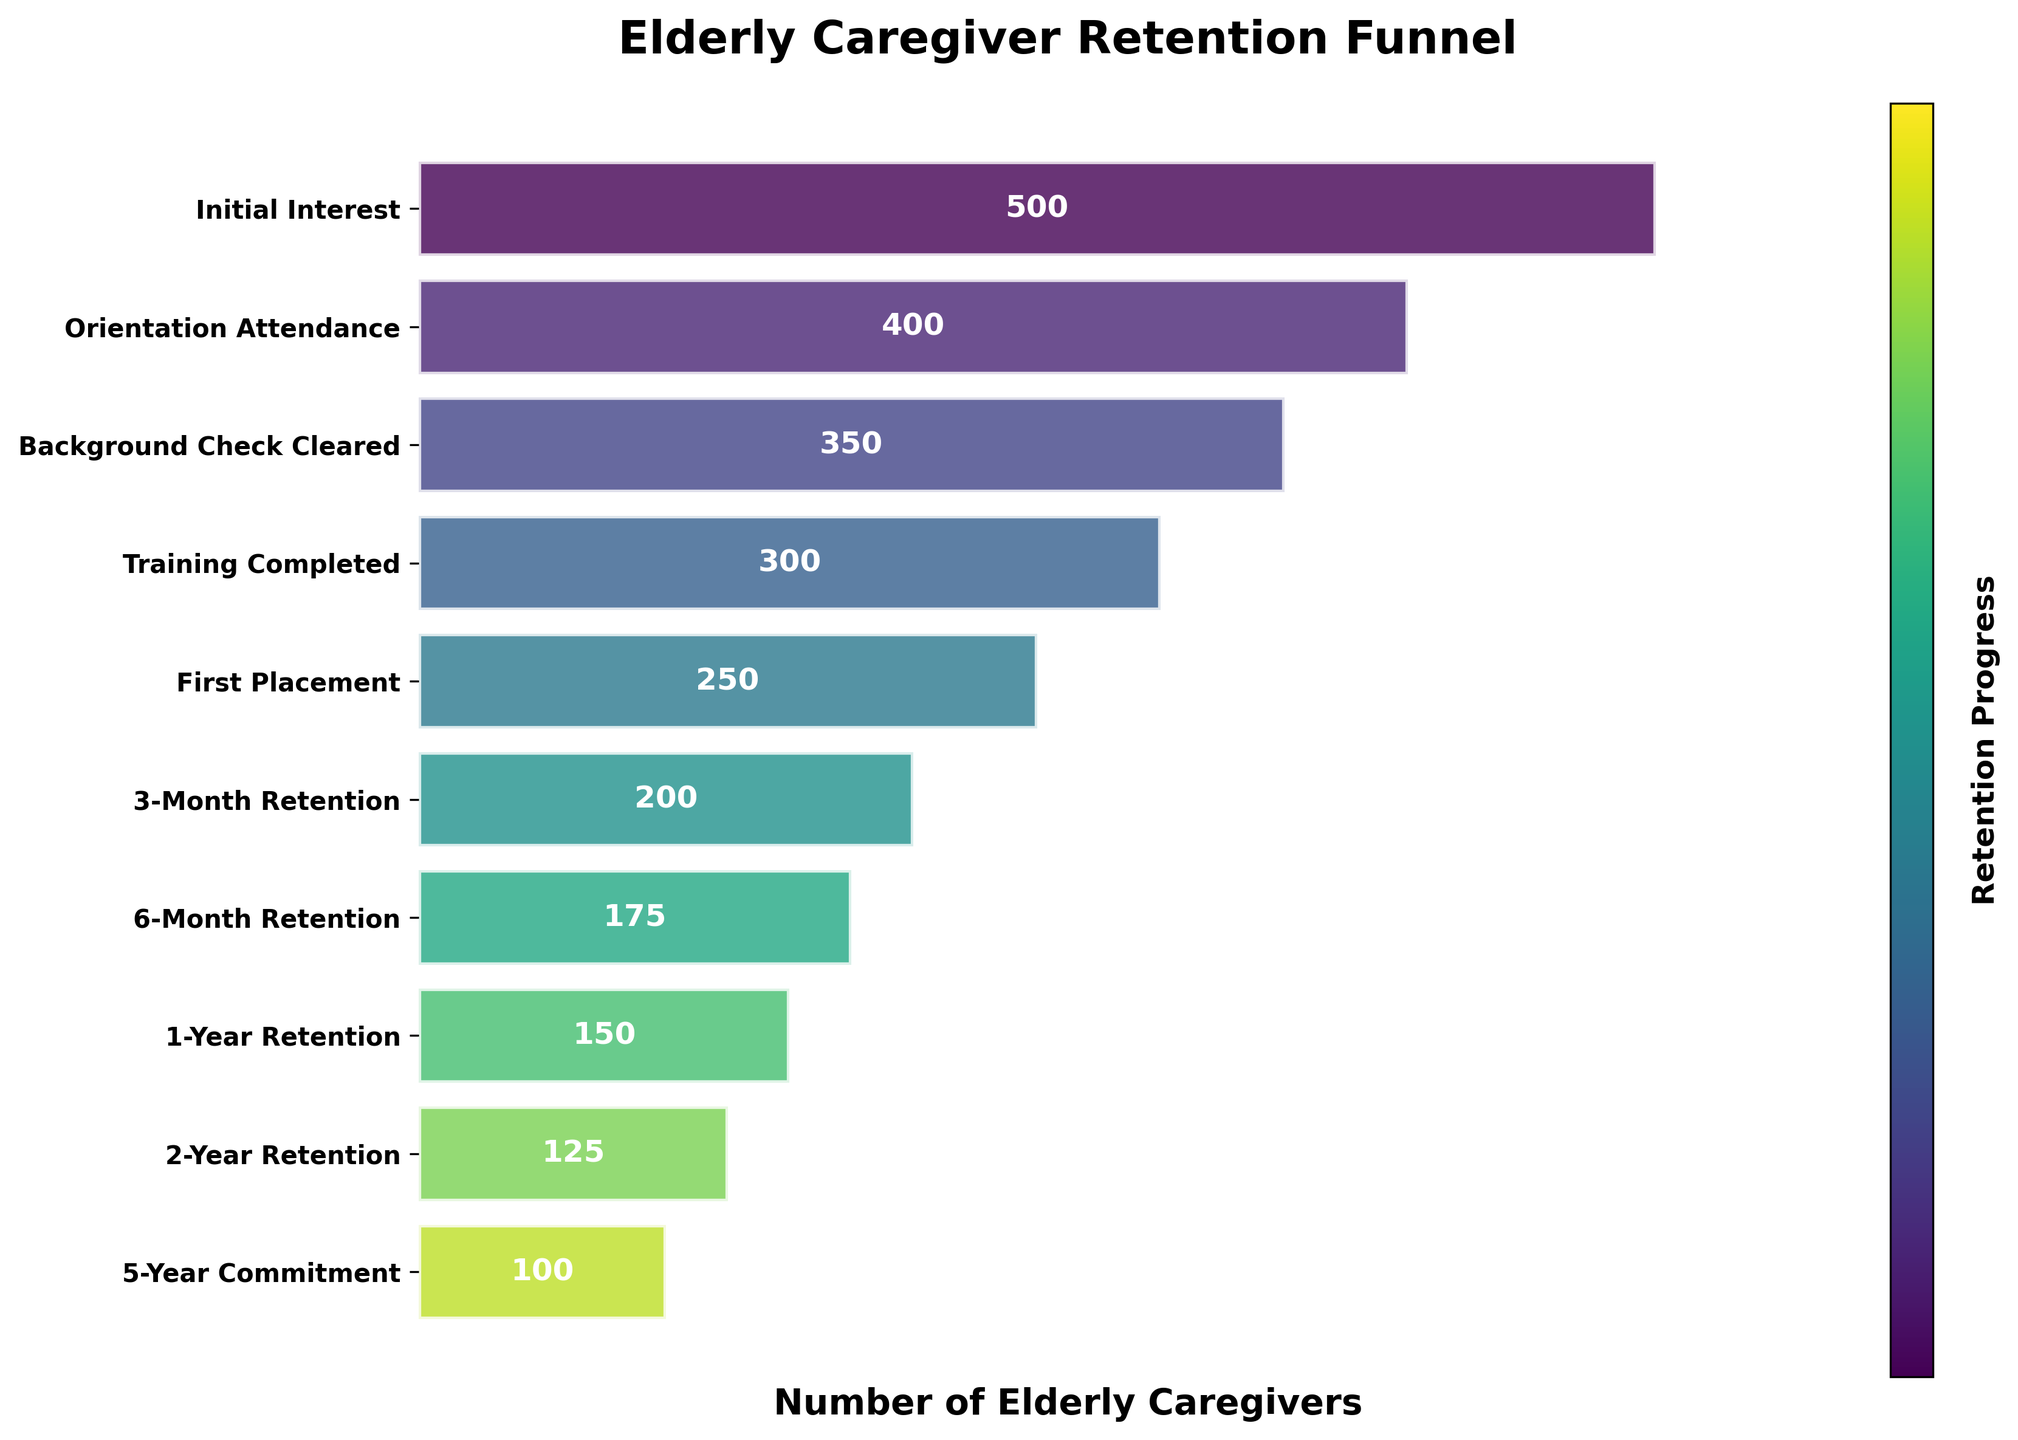What's the title of the figure? The title is usually displayed prominently at the top of a figure. In this case, it is mentioned in the code.
Answer: Elderly Caregiver Retention Funnel How many stages are shown in the funnel chart? Counting the number of stages listed on the y-axis in the figure, we see there are ten stages.
Answer: 10 What is the number of elderly caregivers at the 'Orientation Attendance' stage? From the figure, identify the bar corresponding to the 'Orientation Attendance' stage and read the label inside or on top of the bar.
Answer: 400 How many elderly caregivers completed the 'Training' stage? Locate the 'Training Completed' stage on the y-axis and read the value from the figure.
Answer: 300 Which stage has the largest drop in the number of elderly caregivers compared to the previous stage? Compare the difference in numbers between each consecutive stage by subtracting the values. The largest drop happens between 'Initial Interest' (500) and 'Orientation Attendance' (400).
Answer: Orientation Attendance What is the difference in the number of elderly caregivers between the '3-Month Retention' and '6-Month Retention' stages? Subtract the number at '6-Month Retention' (175) from that at '3-Month Retention' (200): 200 - 175 = 25.
Answer: 25 Which stage marks the halfway point in the number of elderly caregivers from 'Initial Interest' to '5-Year Commitment'? Calculate the halfway number, which is (500 + 100) / 2 = 300, then find the stage closest to this number in the figure. 'Training Completed' is 300.
Answer: Training Completed What is the total number of elderly caregivers retained after the '1-Year Retention' stage? Sum the values from '1-Year Retention' (150) to '5-Year Commitment' (100): 150 + 125 + 100 = 375.
Answer: 375 How does the color scheme progress through the stages? Observe the changes in the colors of the bars from top to bottom. The plot uses a viridis color map which gradually transitions from one color to another as you move down the stages.
Answer: Gradual transition What percentage of elderly caregivers retained after the '6-Month Retention' stage? Divide the '6-Month Retention' number (175) by the 'Initial Interest' number (500) and multiply by 100 to get the percentage: (175 / 500) * 100 = 35%.
Answer: 35% 